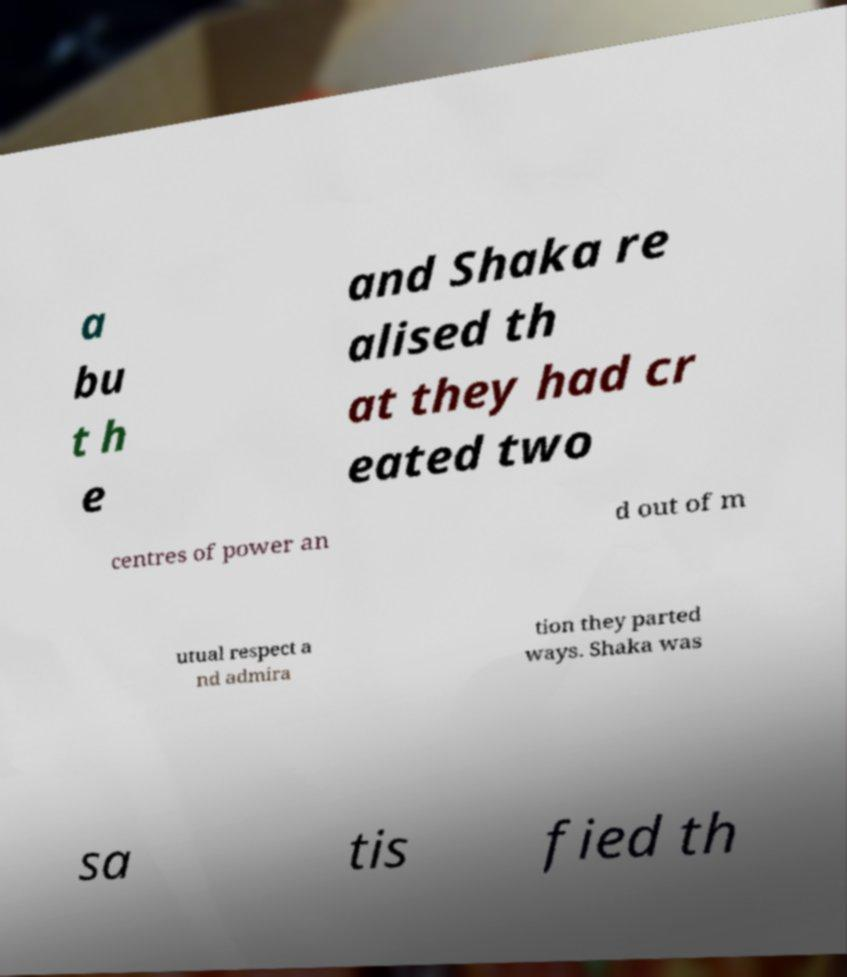Can you accurately transcribe the text from the provided image for me? a bu t h e and Shaka re alised th at they had cr eated two centres of power an d out of m utual respect a nd admira tion they parted ways. Shaka was sa tis fied th 